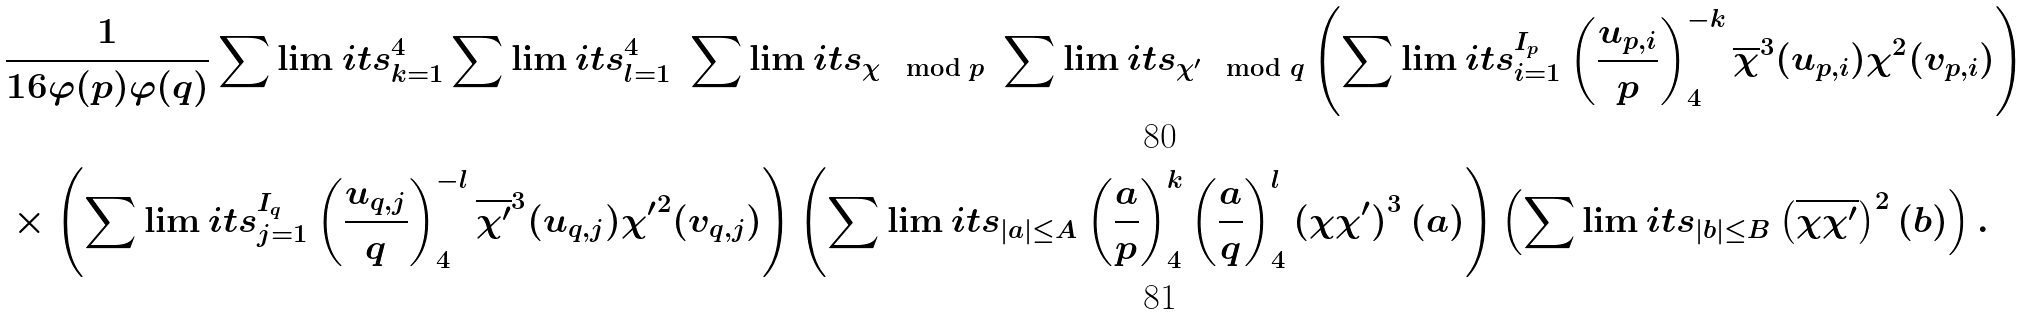<formula> <loc_0><loc_0><loc_500><loc_500>& \frac { 1 } { 1 6 \varphi ( p ) \varphi ( q ) } \sum \lim i t s _ { k = 1 } ^ { 4 } \sum \lim i t s _ { l = 1 } ^ { 4 } \ \sum \lim i t s _ { \chi \ \, \bmod { p } } \ \sum \lim i t s _ { \chi ^ { \prime } \ \, \bmod { q } } \left ( \sum \lim i t s _ { i = 1 } ^ { I _ { p } } \left ( \frac { u _ { p , i } } { p } \right ) _ { 4 } ^ { - k } { \overline { \chi } } ^ { 3 } ( u _ { p , i } ) \chi ^ { 2 } ( v _ { p , i } ) \right ) \\ & \times \left ( \sum \lim i t s _ { j = 1 } ^ { I _ { q } } \left ( \frac { u _ { q , j } } { q } \right ) _ { 4 } ^ { - l } \overline { \chi ^ { \prime } } ^ { 3 } ( u _ { q , j } ) { \chi ^ { \prime } } ^ { 2 } ( v _ { q , j } ) \right ) \left ( \sum \lim i t s _ { | a | \leq A } \left ( \frac { a } { p } \right ) _ { 4 } ^ { k } \left ( \frac { a } { q } \right ) _ { 4 } ^ { l } \left ( \chi { \chi ^ { \prime } } \right ) ^ { 3 } ( a ) \right ) \left ( \sum \lim i t s _ { | b | \leq B } \left ( \overline { \chi \chi ^ { \prime } } \right ) ^ { 2 } ( b ) \right ) .</formula> 